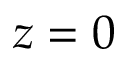<formula> <loc_0><loc_0><loc_500><loc_500>z = 0</formula> 